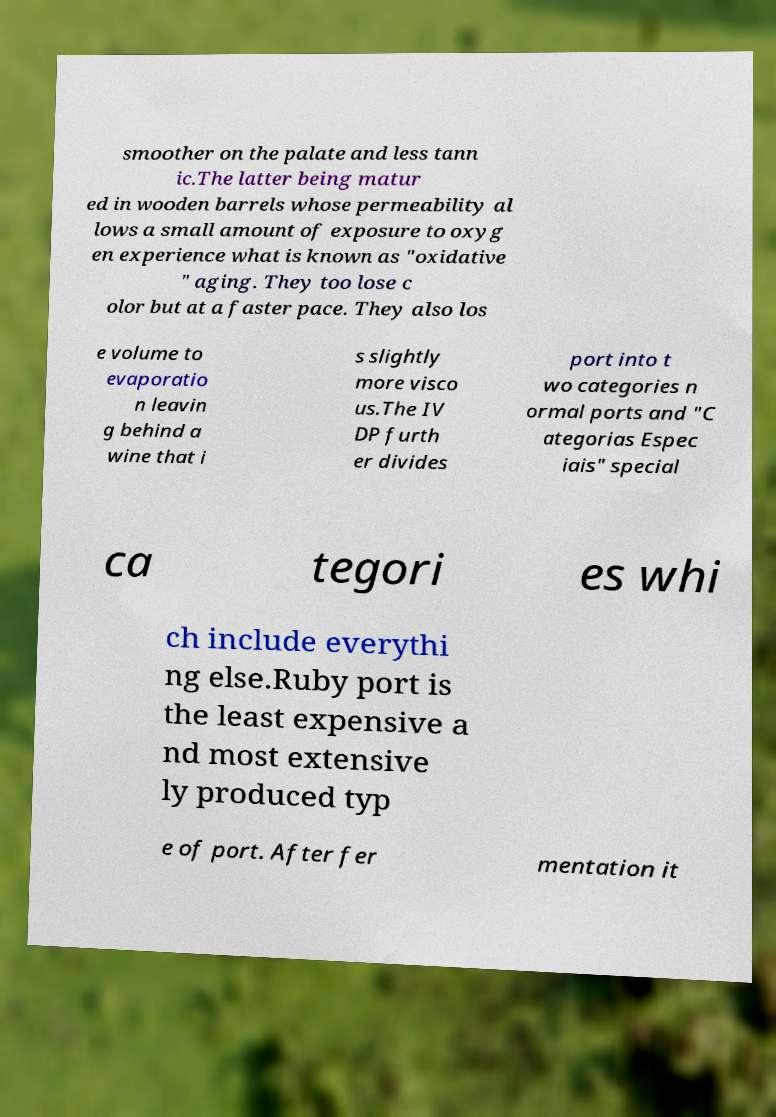Could you assist in decoding the text presented in this image and type it out clearly? smoother on the palate and less tann ic.The latter being matur ed in wooden barrels whose permeability al lows a small amount of exposure to oxyg en experience what is known as "oxidative " aging. They too lose c olor but at a faster pace. They also los e volume to evaporatio n leavin g behind a wine that i s slightly more visco us.The IV DP furth er divides port into t wo categories n ormal ports and "C ategorias Espec iais" special ca tegori es whi ch include everythi ng else.Ruby port is the least expensive a nd most extensive ly produced typ e of port. After fer mentation it 